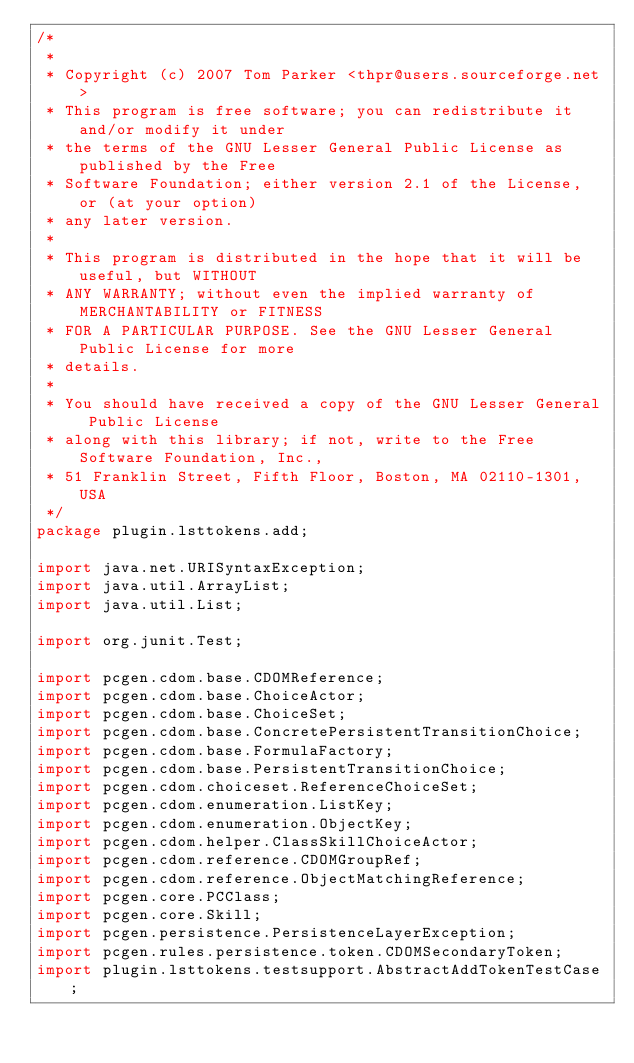Convert code to text. <code><loc_0><loc_0><loc_500><loc_500><_Java_>/*
 * 
 * Copyright (c) 2007 Tom Parker <thpr@users.sourceforge.net>
 * This program is free software; you can redistribute it and/or modify it under
 * the terms of the GNU Lesser General Public License as published by the Free
 * Software Foundation; either version 2.1 of the License, or (at your option)
 * any later version.
 * 
 * This program is distributed in the hope that it will be useful, but WITHOUT
 * ANY WARRANTY; without even the implied warranty of MERCHANTABILITY or FITNESS
 * FOR A PARTICULAR PURPOSE. See the GNU Lesser General Public License for more
 * details.
 * 
 * You should have received a copy of the GNU Lesser General Public License
 * along with this library; if not, write to the Free Software Foundation, Inc.,
 * 51 Franklin Street, Fifth Floor, Boston, MA 02110-1301, USA
 */
package plugin.lsttokens.add;

import java.net.URISyntaxException;
import java.util.ArrayList;
import java.util.List;

import org.junit.Test;

import pcgen.cdom.base.CDOMReference;
import pcgen.cdom.base.ChoiceActor;
import pcgen.cdom.base.ChoiceSet;
import pcgen.cdom.base.ConcretePersistentTransitionChoice;
import pcgen.cdom.base.FormulaFactory;
import pcgen.cdom.base.PersistentTransitionChoice;
import pcgen.cdom.choiceset.ReferenceChoiceSet;
import pcgen.cdom.enumeration.ListKey;
import pcgen.cdom.enumeration.ObjectKey;
import pcgen.cdom.helper.ClassSkillChoiceActor;
import pcgen.cdom.reference.CDOMGroupRef;
import pcgen.cdom.reference.ObjectMatchingReference;
import pcgen.core.PCClass;
import pcgen.core.Skill;
import pcgen.persistence.PersistenceLayerException;
import pcgen.rules.persistence.token.CDOMSecondaryToken;
import plugin.lsttokens.testsupport.AbstractAddTokenTestCase;
</code> 